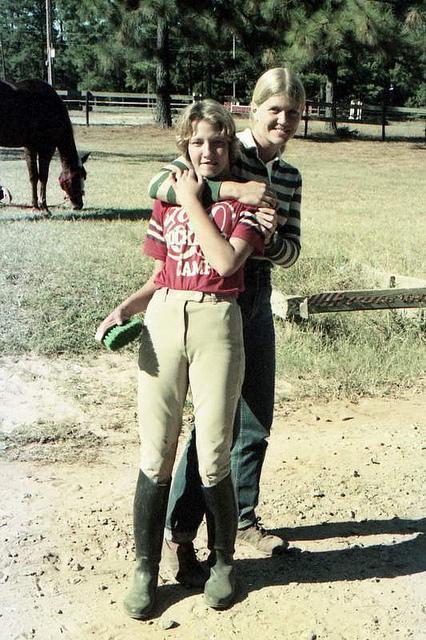What will she use the brush for?
Select the accurate answer and provide justification: `Answer: choice
Rationale: srationale.`
Options: Brush horse, brush hair, sweep ground, clean shoes. Answer: brush horse.
Rationale: A woman is holding a large brush and is wearing riding boots and pants. domesticated horses need to be brushed. 